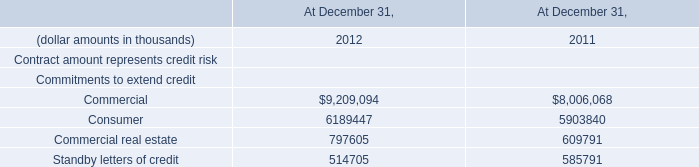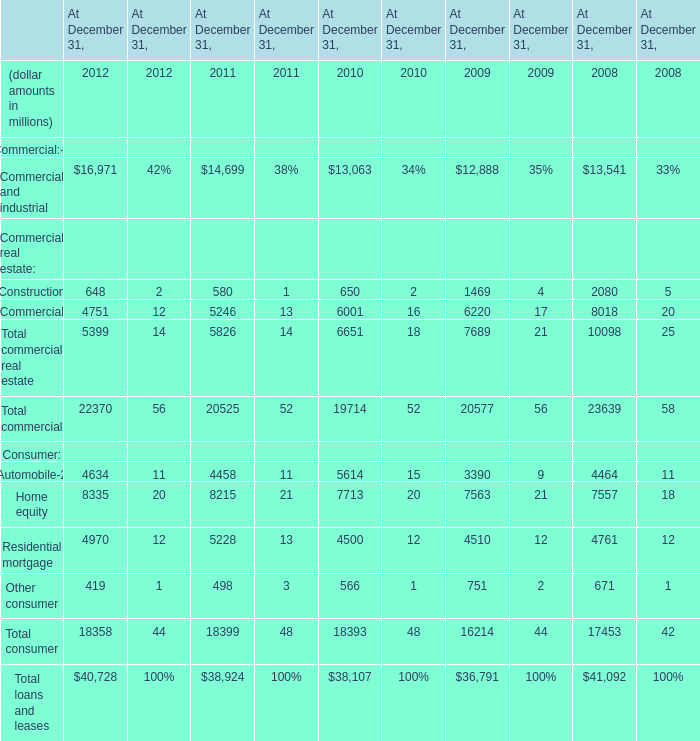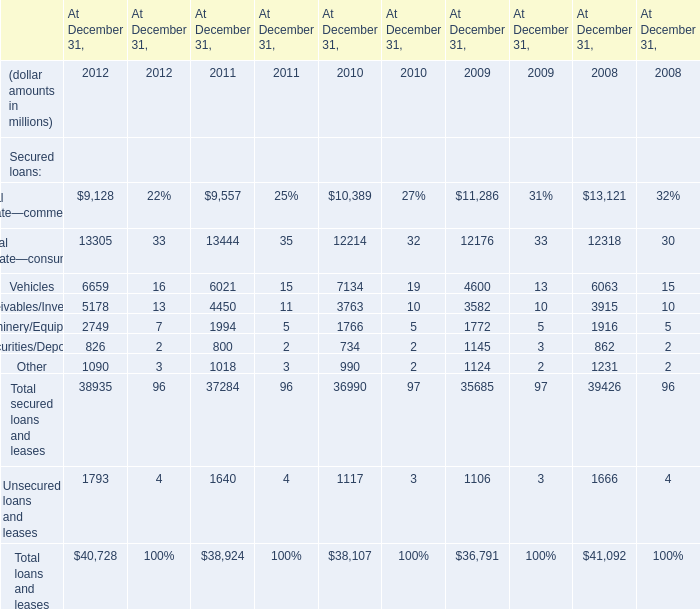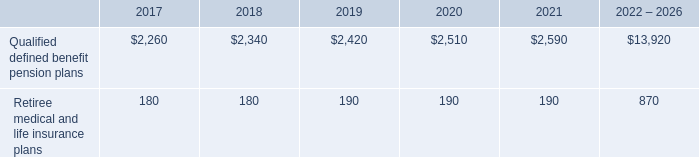What is the sum of elements in 2012 ? (in million) 
Computations: (22370 + 18358)
Answer: 40728.0. 